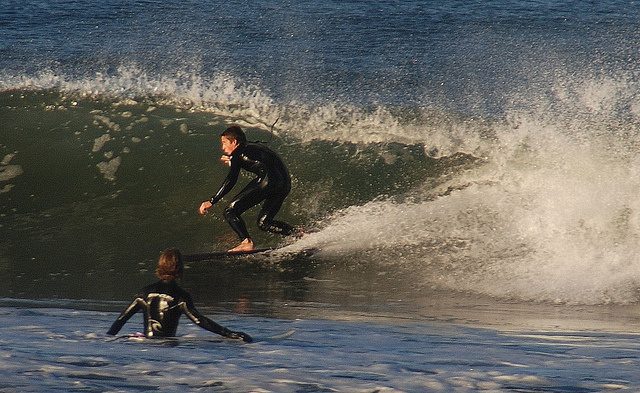Describe the objects in this image and their specific colors. I can see people in darkblue, black, tan, maroon, and gray tones, people in darkblue, black, gray, and maroon tones, surfboard in darkblue, black, and gray tones, and surfboard in darkblue, gray, black, and navy tones in this image. 